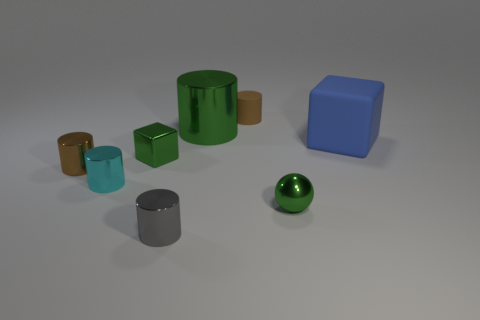Subtract all shiny cylinders. How many cylinders are left? 1 Subtract all brown cylinders. How many cylinders are left? 3 Subtract all cylinders. How many objects are left? 3 Add 2 matte cubes. How many objects exist? 10 Subtract 2 cylinders. How many cylinders are left? 3 Subtract all green metal blocks. Subtract all big blue things. How many objects are left? 6 Add 1 big green shiny things. How many big green shiny things are left? 2 Add 6 big blue objects. How many big blue objects exist? 7 Subtract 0 purple balls. How many objects are left? 8 Subtract all gray balls. Subtract all purple cylinders. How many balls are left? 1 